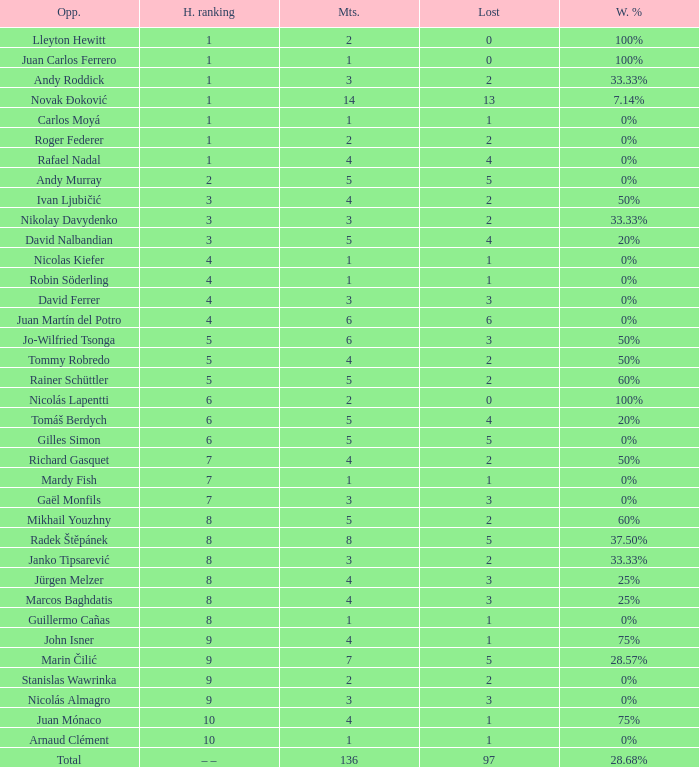What is the largest number Lost to david nalbandian with a Win Rate of 20%? 4.0. 